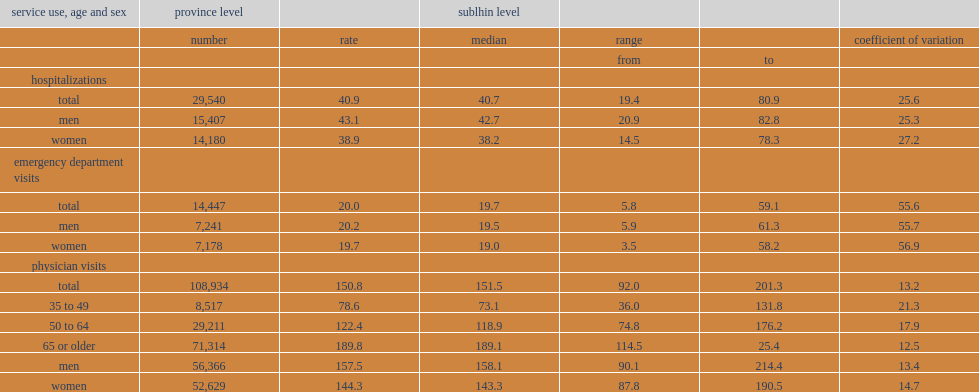What was the overall rate of hospitallizations per 1,000 prevalent cases of copd? 40.9. What was the overall rate of hospitallizations per 1,000 men prevalent cases of copd? 43.1. What was the overall rate of hospitallizations per 1,000 women prevalent cases of copd? 38.9. What was the total number of copd-specific emergency department visits took place during the study period? 14447.0. What was the number of copd-specific physician visits recorded over the study period? 108934.0. What was the number of physician visits per 1,000 prevalent cases over the study period? 150.8. Which age groups with copd had the highest rate of physician visits? 65 or older. 